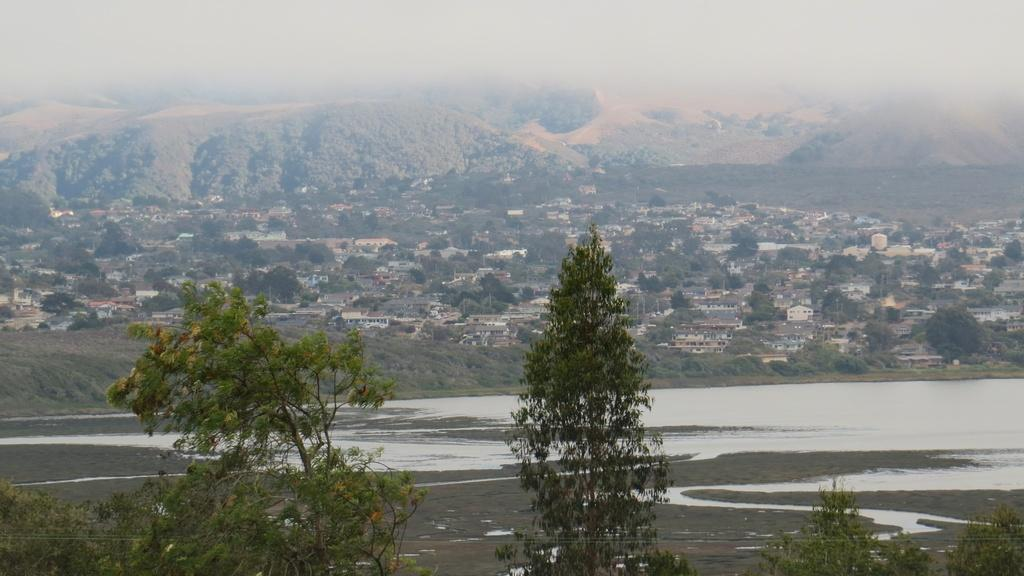What is located in the foreground of the image? There is a group of trees and water visible in the foreground of the image. What can be seen in the background of the image? There is a group of buildings, mountains, and the sky visible in the background of the image. What is the price of the wing that is visible in the image? There is no wing present in the image, so it is not possible to determine its price. 